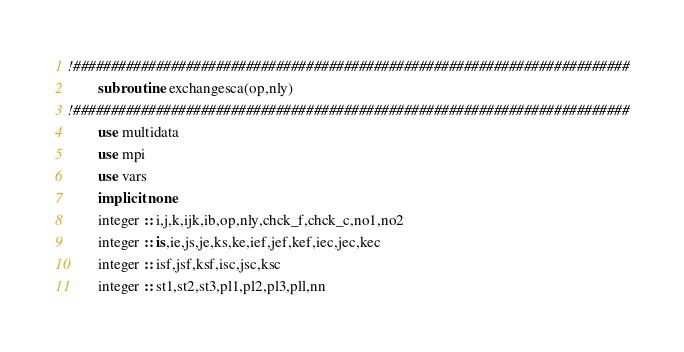<code> <loc_0><loc_0><loc_500><loc_500><_FORTRAN_>!##########################################################################
        subroutine  exchangesca(op,nly)
!##########################################################################
        use multidata
        use mpi
        use vars
        implicit none
        integer :: i,j,k,ijk,ib,op,nly,chck_f,chck_c,no1,no2
        integer :: is,ie,js,je,ks,ke,ief,jef,kef,iec,jec,kec
        integer :: isf,jsf,ksf,isc,jsc,ksc
        integer :: st1,st2,st3,pl1,pl2,pl3,pll,nn</code> 